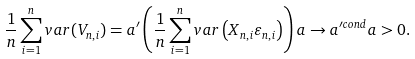<formula> <loc_0><loc_0><loc_500><loc_500>\frac { 1 } { n } \sum _ { i = 1 } ^ { n } v a r ( V _ { n , i } ) = a ^ { \prime } \left ( \frac { 1 } { n } \sum _ { i = 1 } ^ { n } v a r \left ( X _ { n , i } \varepsilon _ { n , i } \right ) \right ) a \rightarrow a ^ { \prime c o n d } a > 0 .</formula> 